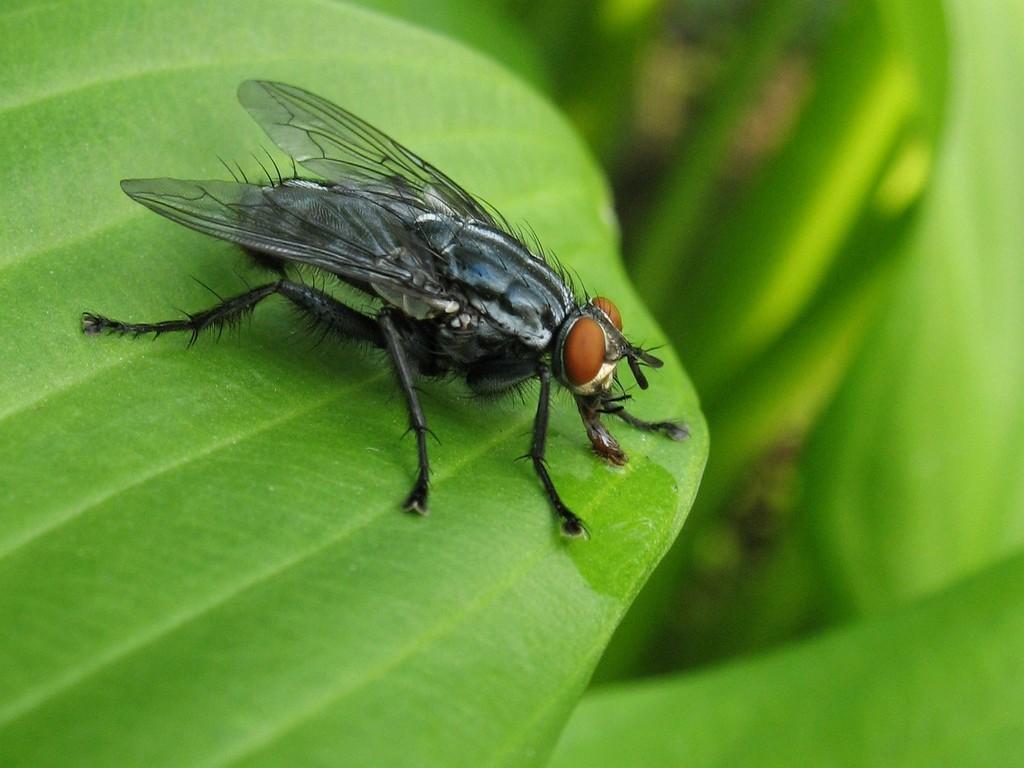In one or two sentences, can you explain what this image depicts? In this image we can see an insect on the leaf and the background is blurred. 